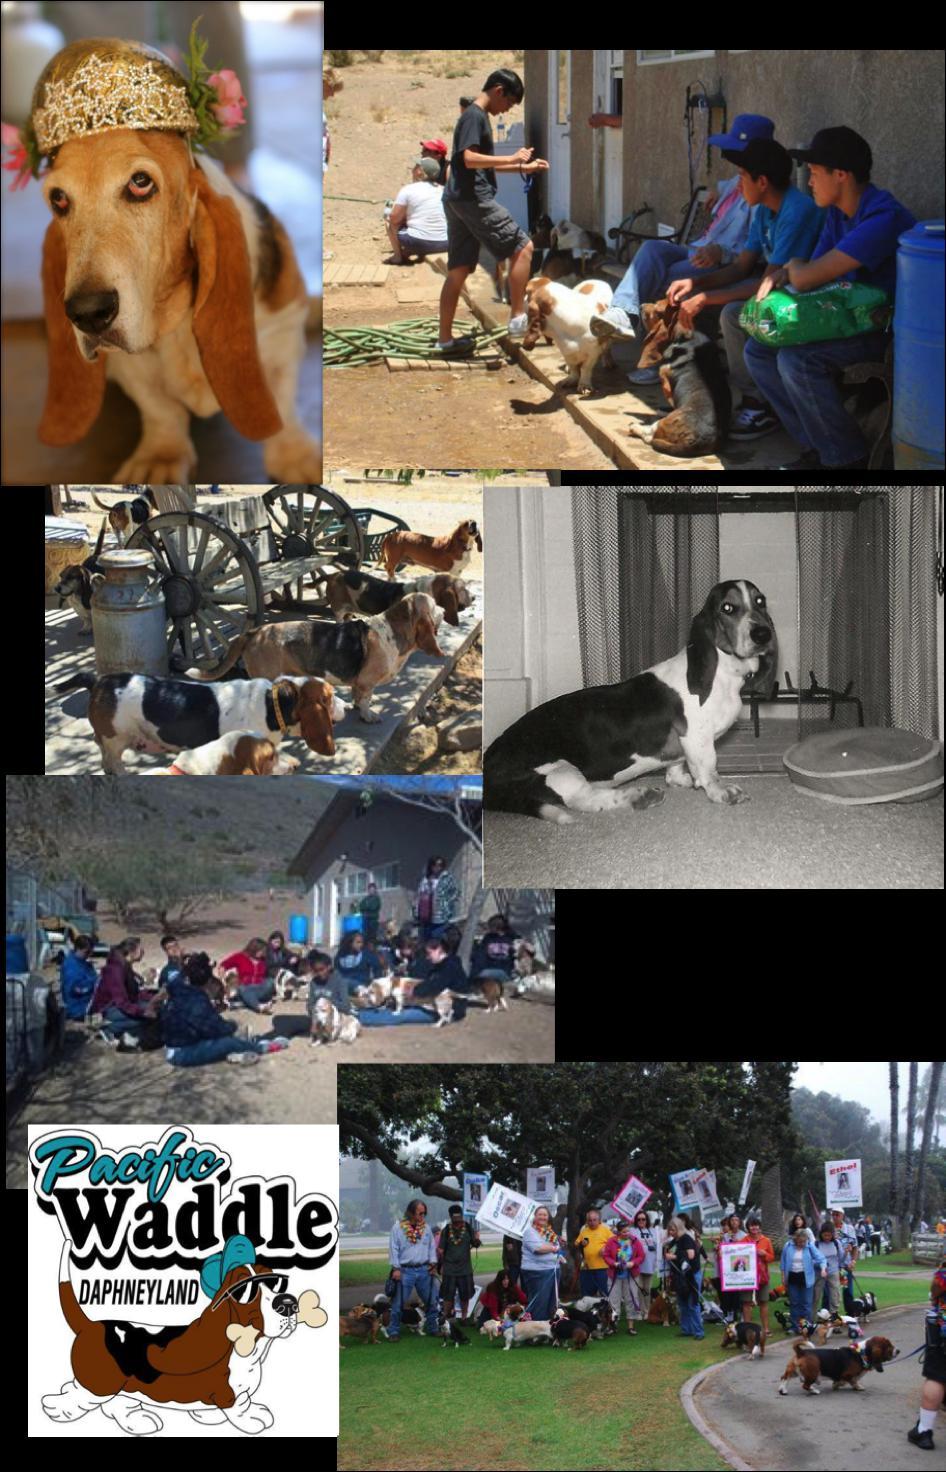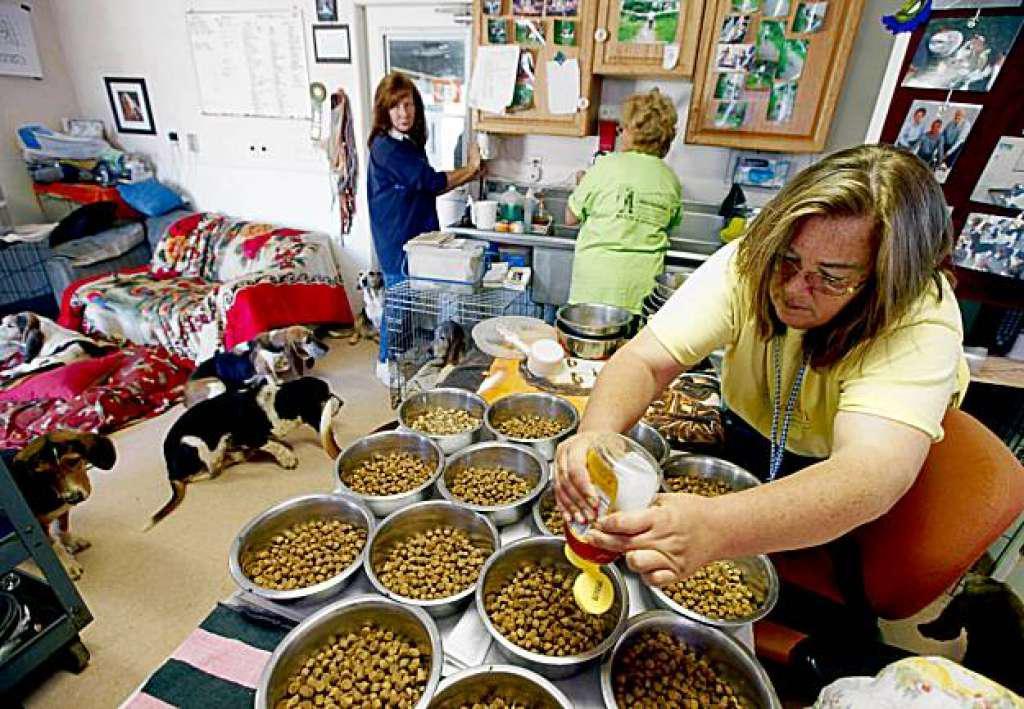The first image is the image on the left, the second image is the image on the right. Examine the images to the left and right. Is the description "An image shows a person behind a wash bucket containing a basset hound." accurate? Answer yes or no. No. The first image is the image on the left, the second image is the image on the right. For the images displayed, is the sentence "A person in a tank top is bathing a dog outside." factually correct? Answer yes or no. No. 